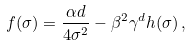<formula> <loc_0><loc_0><loc_500><loc_500>f ( \sigma ) = \frac { \alpha d } { 4 \sigma ^ { 2 } } - \beta ^ { 2 } \gamma ^ { d } h ( \sigma ) \, ,</formula> 